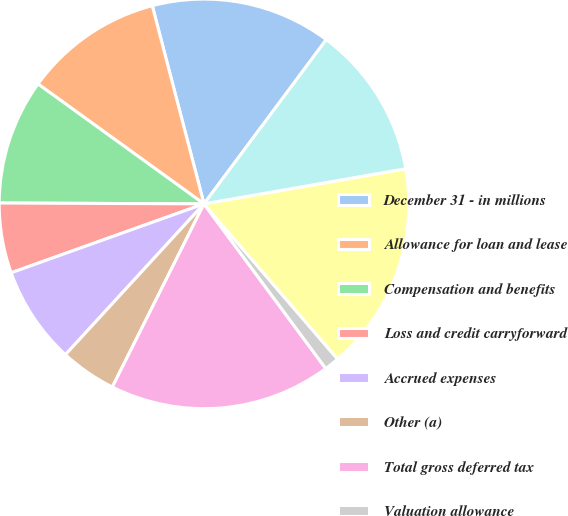Convert chart to OTSL. <chart><loc_0><loc_0><loc_500><loc_500><pie_chart><fcel>December 31 - in millions<fcel>Allowance for loan and lease<fcel>Compensation and benefits<fcel>Loss and credit carryforward<fcel>Accrued expenses<fcel>Other (a)<fcel>Total gross deferred tax<fcel>Valuation allowance<fcel>Total deferred tax assets<fcel>Leasing<nl><fcel>14.25%<fcel>10.98%<fcel>9.89%<fcel>5.53%<fcel>7.71%<fcel>4.44%<fcel>17.52%<fcel>1.18%<fcel>16.43%<fcel>12.07%<nl></chart> 